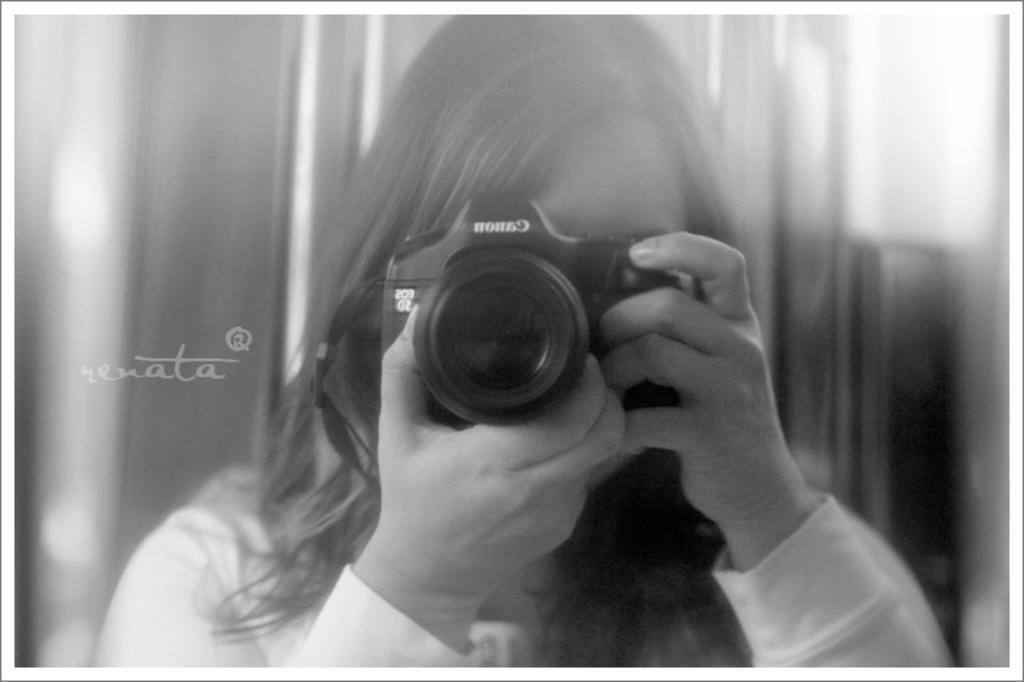Please provide a concise description of this image. This is a black and white picture. In the picture the woman is holding a canon black camera. Behind the woman is in blue. 